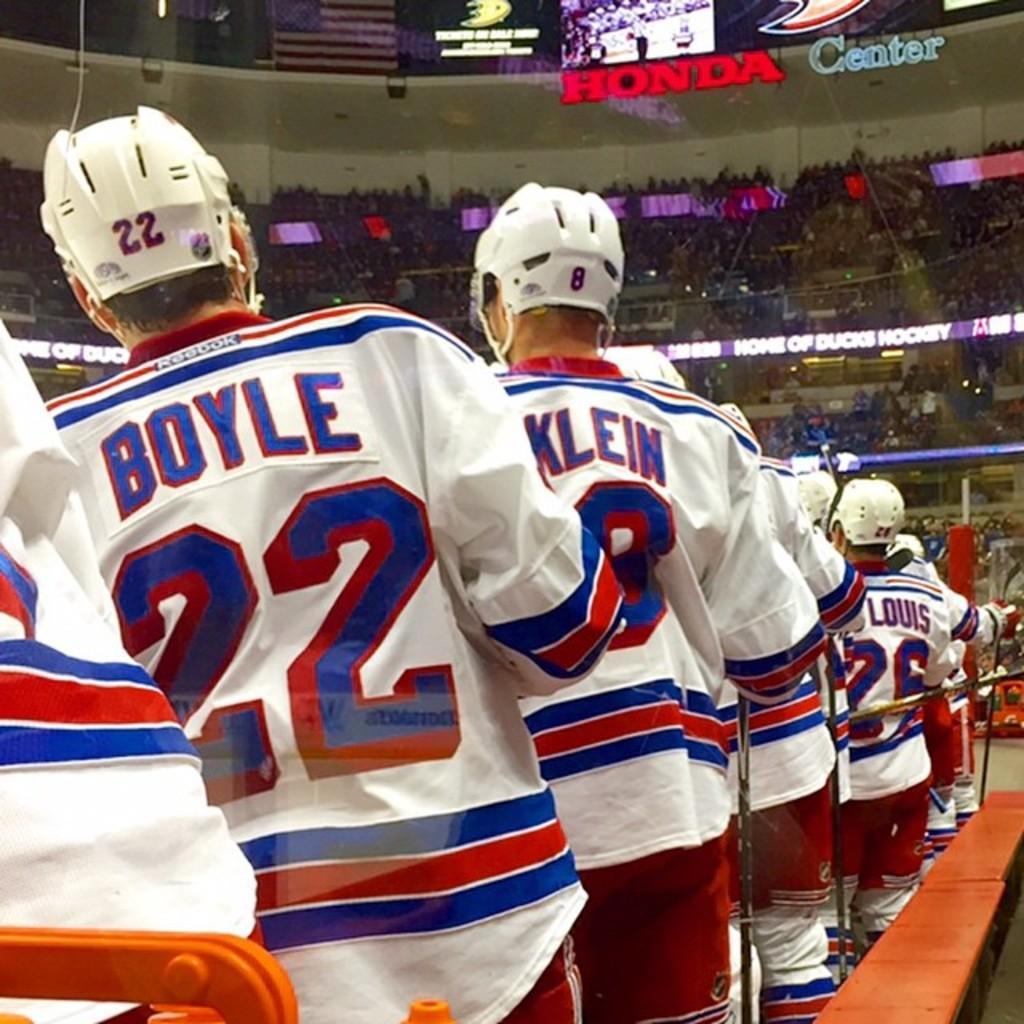What are the people in the image doing? The people in the image are standing in a queue. What can be seen in the background of the image? There are many people in the background of the image. What is located at the top of the image? There is a text with lights on the top of the image. What type of advice can be seen on the wall in the image? There is no wall or advice present in the image. 